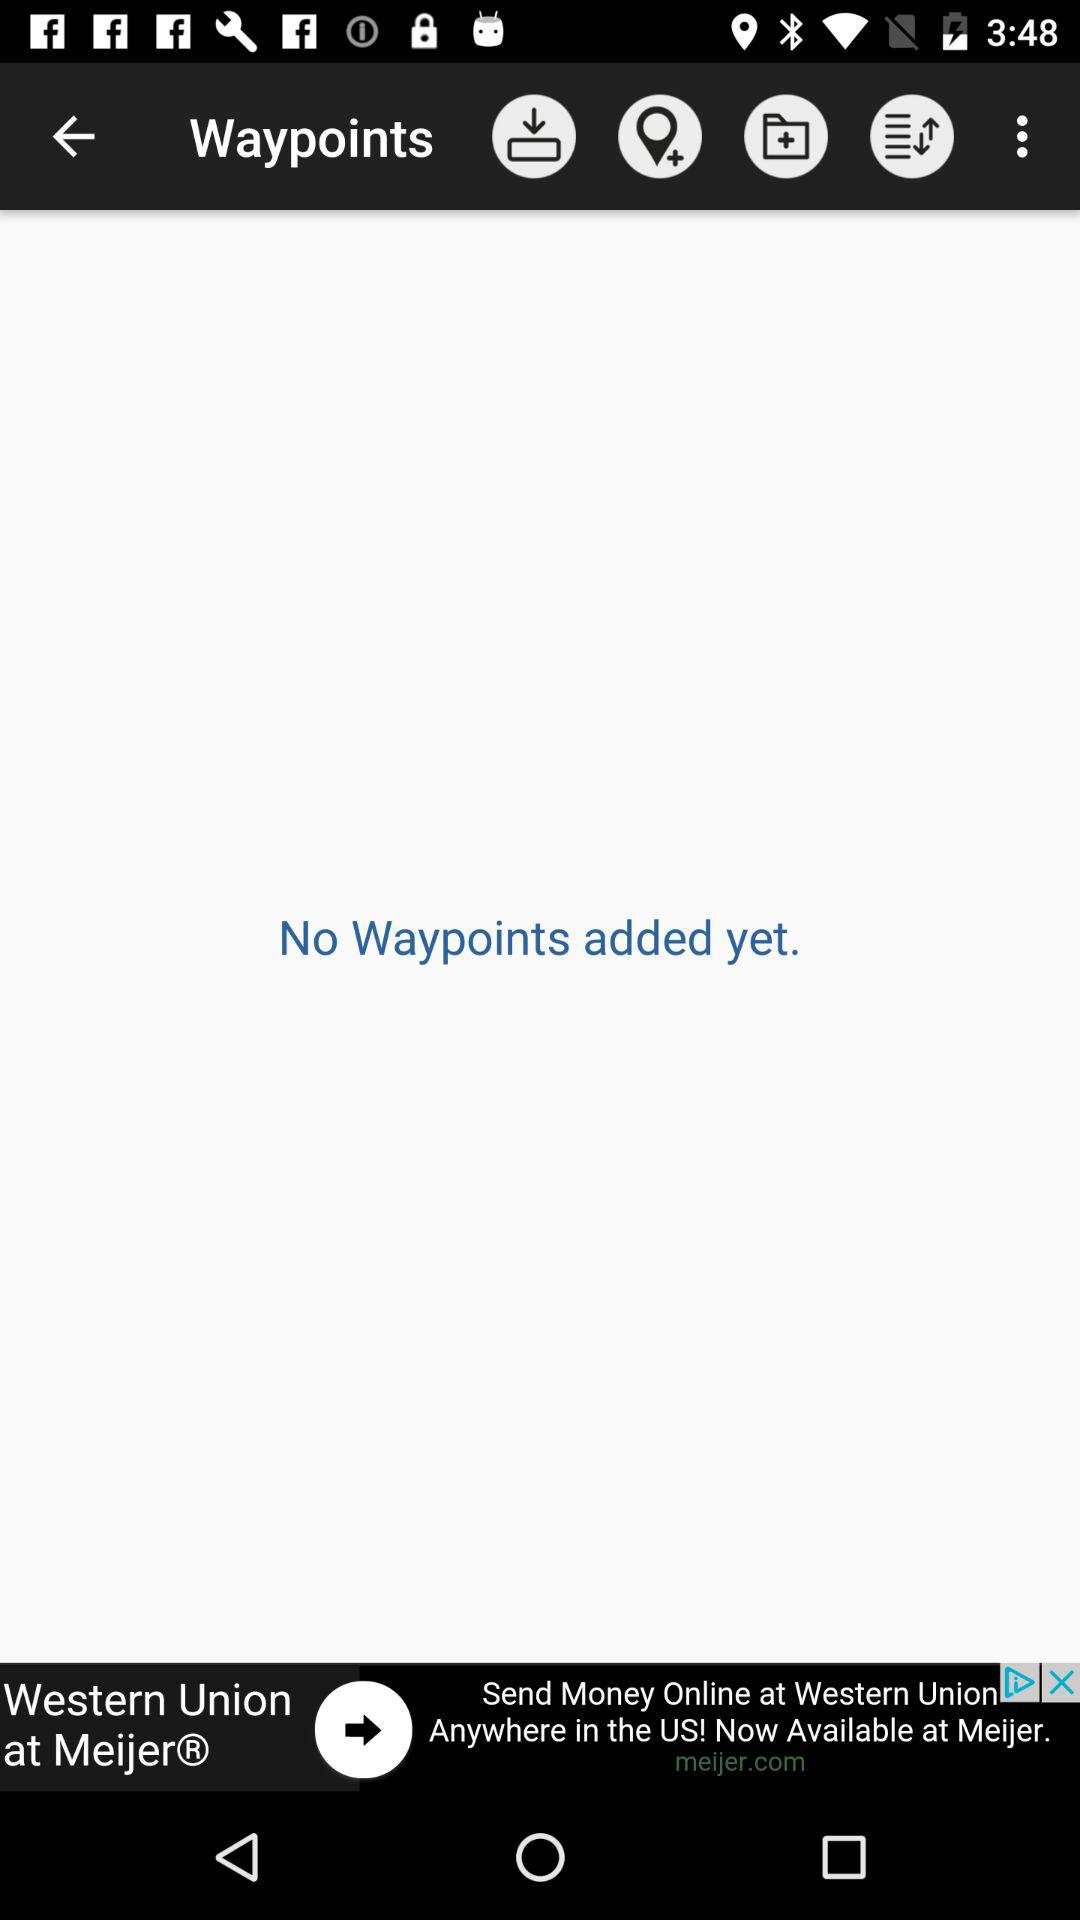Are there any Waypoints? There are no Waypoints. 